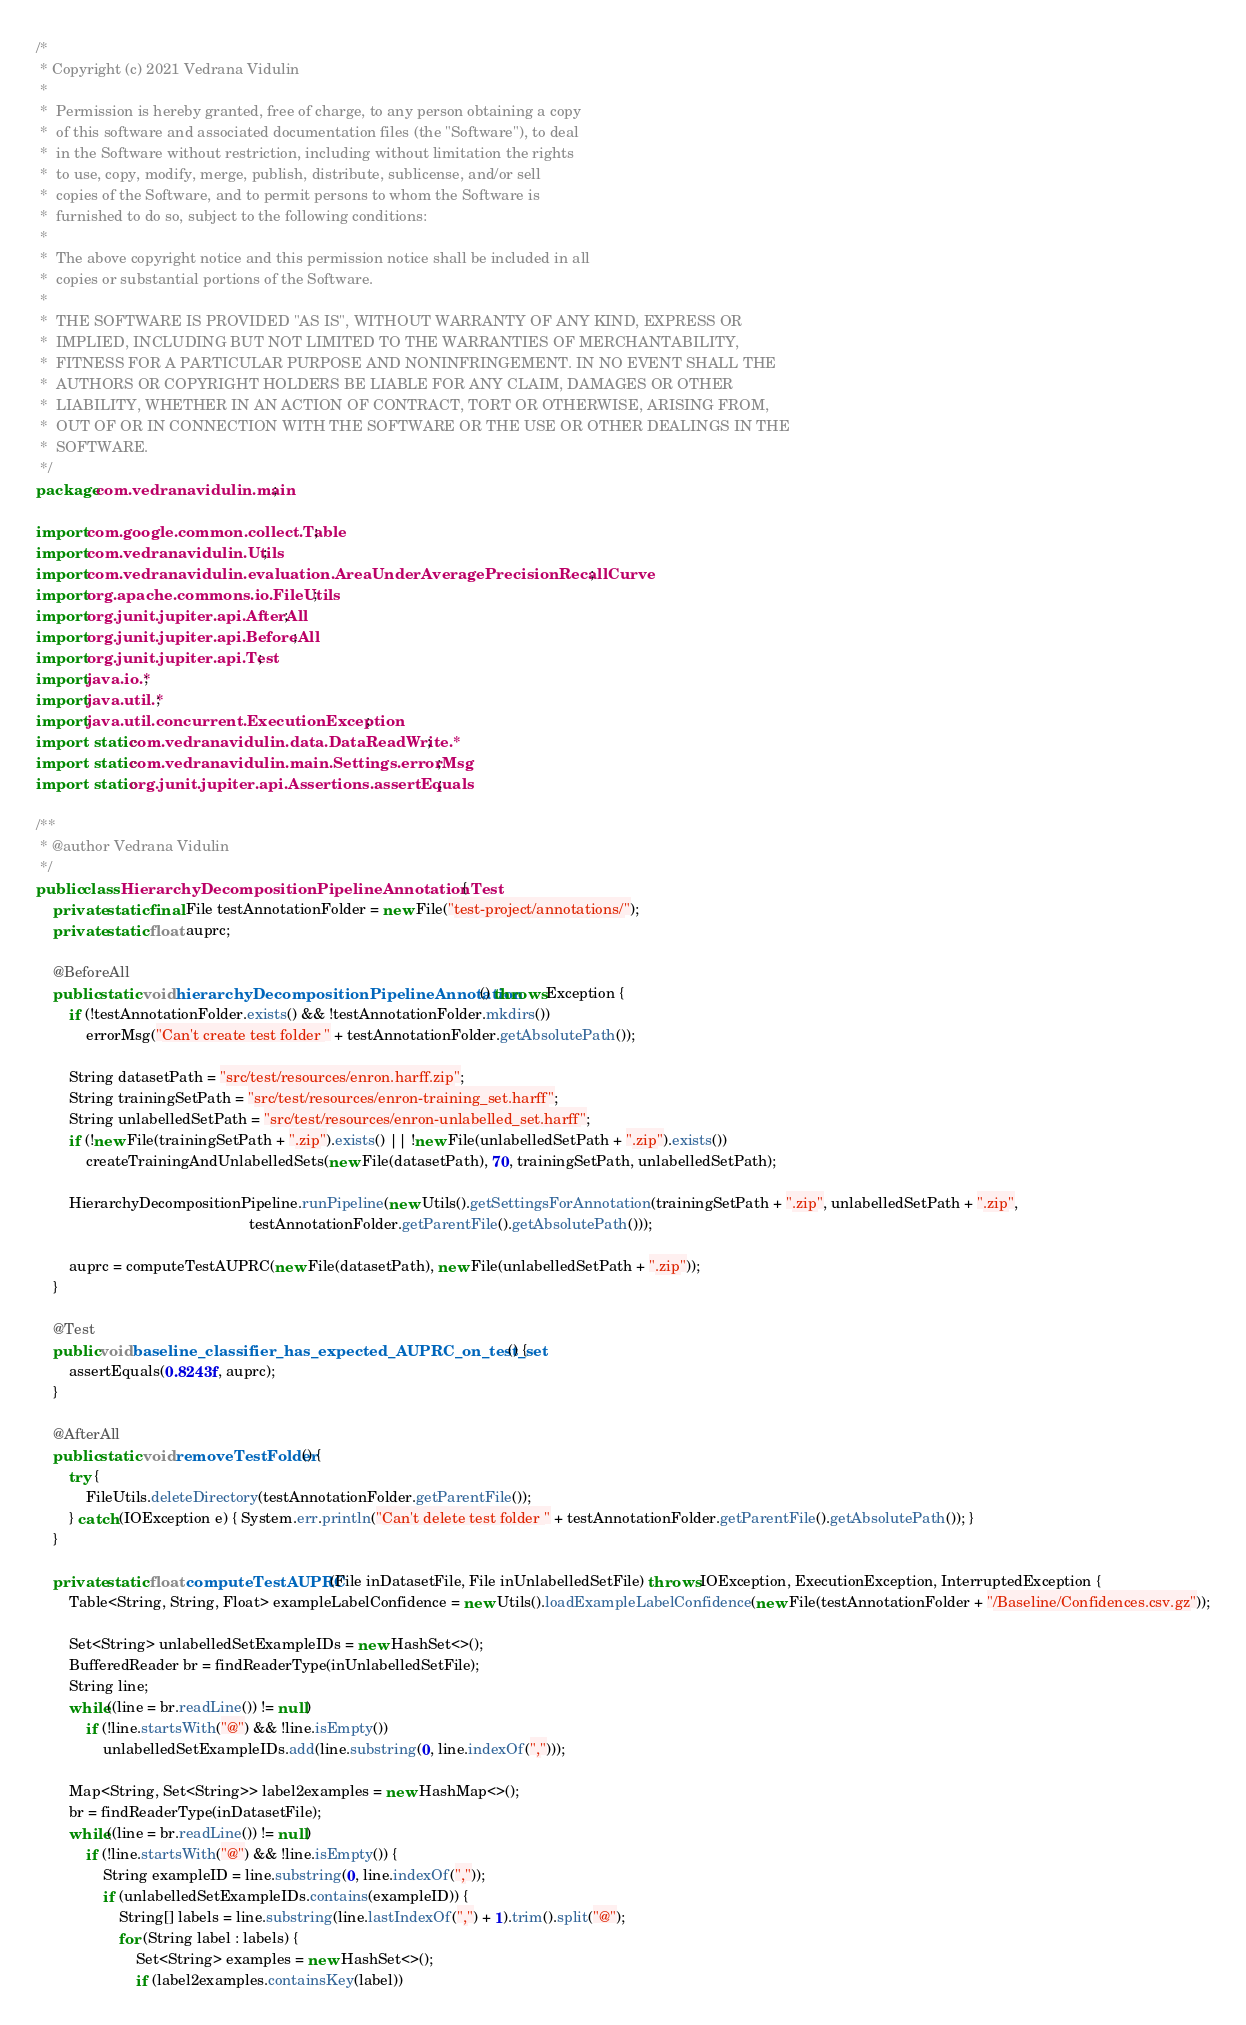Convert code to text. <code><loc_0><loc_0><loc_500><loc_500><_Java_>/*
 * Copyright (c) 2021 Vedrana Vidulin
 *
 *  Permission is hereby granted, free of charge, to any person obtaining a copy
 *  of this software and associated documentation files (the "Software"), to deal
 *  in the Software without restriction, including without limitation the rights
 *  to use, copy, modify, merge, publish, distribute, sublicense, and/or sell
 *  copies of the Software, and to permit persons to whom the Software is
 *  furnished to do so, subject to the following conditions:
 *
 *  The above copyright notice and this permission notice shall be included in all
 *  copies or substantial portions of the Software.
 *
 *  THE SOFTWARE IS PROVIDED "AS IS", WITHOUT WARRANTY OF ANY KIND, EXPRESS OR
 *  IMPLIED, INCLUDING BUT NOT LIMITED TO THE WARRANTIES OF MERCHANTABILITY,
 *  FITNESS FOR A PARTICULAR PURPOSE AND NONINFRINGEMENT. IN NO EVENT SHALL THE
 *  AUTHORS OR COPYRIGHT HOLDERS BE LIABLE FOR ANY CLAIM, DAMAGES OR OTHER
 *  LIABILITY, WHETHER IN AN ACTION OF CONTRACT, TORT OR OTHERWISE, ARISING FROM,
 *  OUT OF OR IN CONNECTION WITH THE SOFTWARE OR THE USE OR OTHER DEALINGS IN THE
 *  SOFTWARE.
 */
package com.vedranavidulin.main;

import com.google.common.collect.Table;
import com.vedranavidulin.Utils;
import com.vedranavidulin.evaluation.AreaUnderAveragePrecisionRecallCurve;
import org.apache.commons.io.FileUtils;
import org.junit.jupiter.api.AfterAll;
import org.junit.jupiter.api.BeforeAll;
import org.junit.jupiter.api.Test;
import java.io.*;
import java.util.*;
import java.util.concurrent.ExecutionException;
import static com.vedranavidulin.data.DataReadWrite.*;
import static com.vedranavidulin.main.Settings.errorMsg;
import static org.junit.jupiter.api.Assertions.assertEquals;

/**
 * @author Vedrana Vidulin
 */
public class HierarchyDecompositionPipelineAnnotationTest {
    private static final File testAnnotationFolder = new File("test-project/annotations/");
    private static float auprc;

    @BeforeAll
    public static void hierarchyDecompositionPipelineAnnotation() throws Exception {
        if (!testAnnotationFolder.exists() && !testAnnotationFolder.mkdirs())
            errorMsg("Can't create test folder " + testAnnotationFolder.getAbsolutePath());

        String datasetPath = "src/test/resources/enron.harff.zip";
        String trainingSetPath = "src/test/resources/enron-training_set.harff";
        String unlabelledSetPath = "src/test/resources/enron-unlabelled_set.harff";
        if (!new File(trainingSetPath + ".zip").exists() || !new File(unlabelledSetPath + ".zip").exists())
            createTrainingAndUnlabelledSets(new File(datasetPath), 70, trainingSetPath, unlabelledSetPath);

        HierarchyDecompositionPipeline.runPipeline(new Utils().getSettingsForAnnotation(trainingSetPath + ".zip", unlabelledSetPath + ".zip",
                                                   testAnnotationFolder.getParentFile().getAbsolutePath()));

        auprc = computeTestAUPRC(new File(datasetPath), new File(unlabelledSetPath + ".zip"));
    }

    @Test
    public void baseline_classifier_has_expected_AUPRC_on_test_set() {
        assertEquals(0.8243f, auprc);
    }

    @AfterAll
    public static void removeTestFolder() {
        try {
            FileUtils.deleteDirectory(testAnnotationFolder.getParentFile());
        } catch (IOException e) { System.err.println("Can't delete test folder " + testAnnotationFolder.getParentFile().getAbsolutePath()); }
    }

    private static float computeTestAUPRC(File inDatasetFile, File inUnlabelledSetFile) throws IOException, ExecutionException, InterruptedException {
        Table<String, String, Float> exampleLabelConfidence = new Utils().loadExampleLabelConfidence(new File(testAnnotationFolder + "/Baseline/Confidences.csv.gz"));

        Set<String> unlabelledSetExampleIDs = new HashSet<>();
        BufferedReader br = findReaderType(inUnlabelledSetFile);
        String line;
        while((line = br.readLine()) != null)
            if (!line.startsWith("@") && !line.isEmpty())
                unlabelledSetExampleIDs.add(line.substring(0, line.indexOf(",")));

        Map<String, Set<String>> label2examples = new HashMap<>();
        br = findReaderType(inDatasetFile);
        while((line = br.readLine()) != null)
            if (!line.startsWith("@") && !line.isEmpty()) {
                String exampleID = line.substring(0, line.indexOf(","));
                if (unlabelledSetExampleIDs.contains(exampleID)) {
                    String[] labels = line.substring(line.lastIndexOf(",") + 1).trim().split("@");
                    for (String label : labels) {
                        Set<String> examples = new HashSet<>();
                        if (label2examples.containsKey(label))</code> 